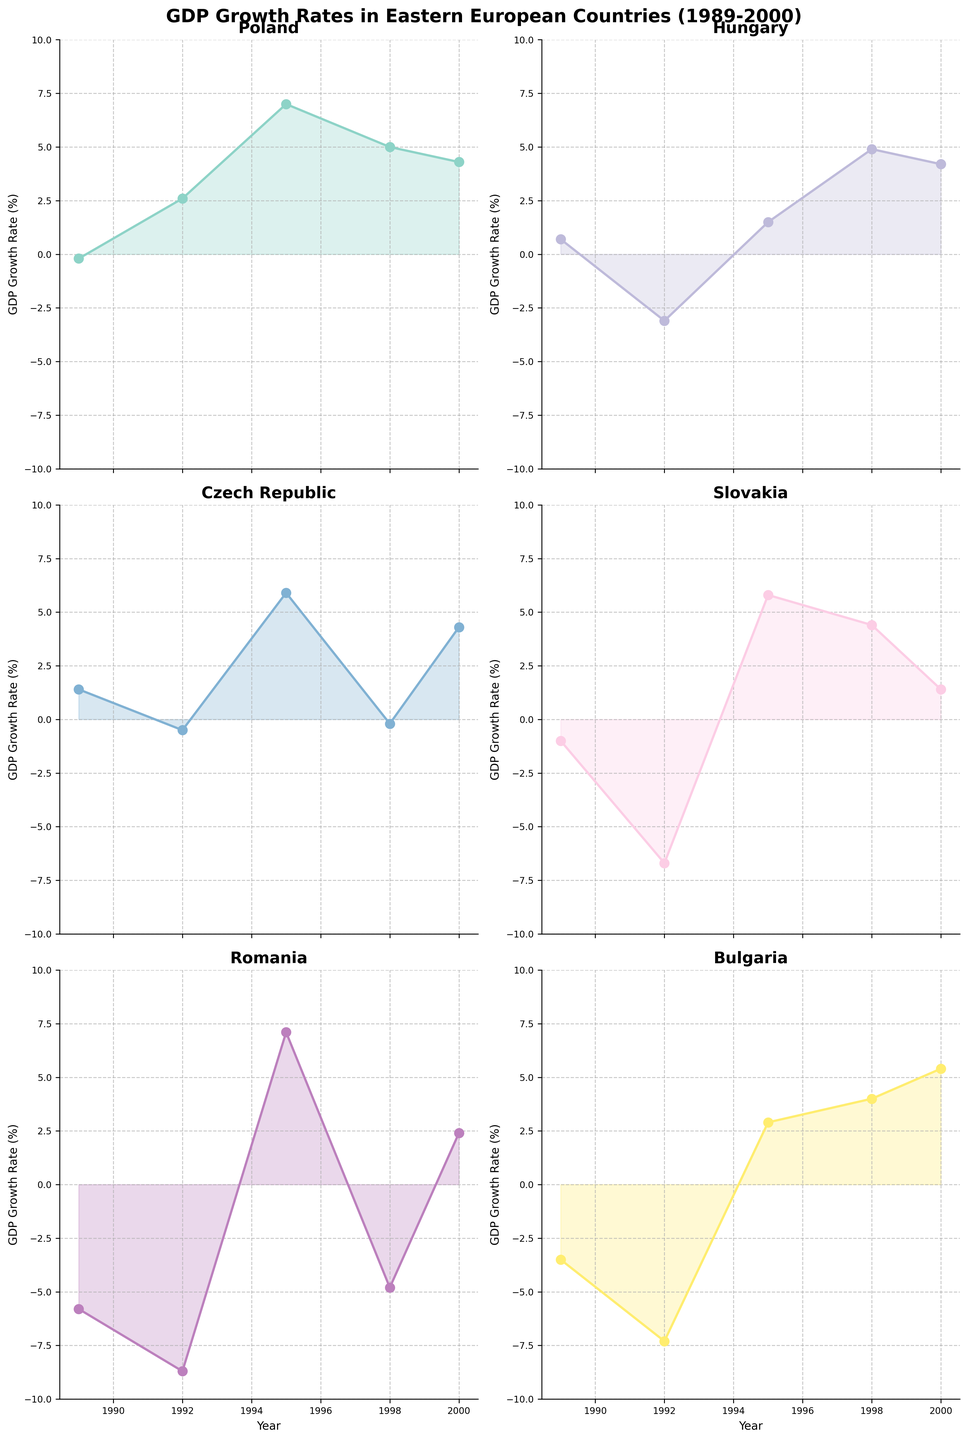What is the title of the figure? The title is found at the top of the figure, often in a larger and bold font. It provides a summary of what the figure represents. In this case, it shows general information about GDP growth rates in different Eastern European countries over a specified period.
Answer: "GDP Growth Rates in Eastern European Countries (1989-2000)" Which country experienced the highest GDP growth rate in 1995? You need to look at the subplot for each country and identify the year 1995. Then compare the GDP growth rates for that year across all countries to find the highest value.
Answer: Romania How did Hungary's GDP growth rate change between 1989 and 1992? Examine Hungary's subplot and note the GDP growth rate in 1989 and 1992. Calculate the difference between these two values.
Answer: -3.8 Which country had a negative GDP growth rate in 1998? Look at each subplot to find the year 1998 and check the GDP growth rates for all the countries. Identify which subplot shows a negative value for that year.
Answer: Romania and Czech Republic Rank the countries based on their GDP growth rate in the year 2000 from highest to lowest. Look at each subplot to find the GDP growth rate in 2000. Note these values and then sort them in descending order.
Answer: Bulgaria, Poland, Czech Republic, Hungary, Romania, Slovakia What was the average GDP growth rate for Poland between 1989 and 2000? Find Poland's GDP growth rates for each of the years 1989, 1992, 1995, 1998, and 2000. Sum these values and divide by the total number of years.
Answer: 3.74 Which country had the most significant fluctuation in GDP growth rate between 1989 and 1992? Look at the change in GDP growth rates between 1989 and 1992 for each country. Calculate the absolute difference for each country and identify the largest change.
Answer: Romania Did any country experience a continuously increasing GDP growth rate during the observed years? Examine each subplot and check if any country has a trend where the GDP growth rate increases year over year without declining in any year.
Answer: No Between Slovakia and Bulgaria, which country had a higher GDP growth rate in 1998? Compare the GDP growth rates in 1998 shown in the subplots for Slovakia and Bulgaria.
Answer: Slovakia How many countries reached a GDP growth rate of 5% or higher at least once during the time period? Review each subplot and count the number of countries that have at least one instance where the GDP growth rate is 5% or higher.
Answer: 4 